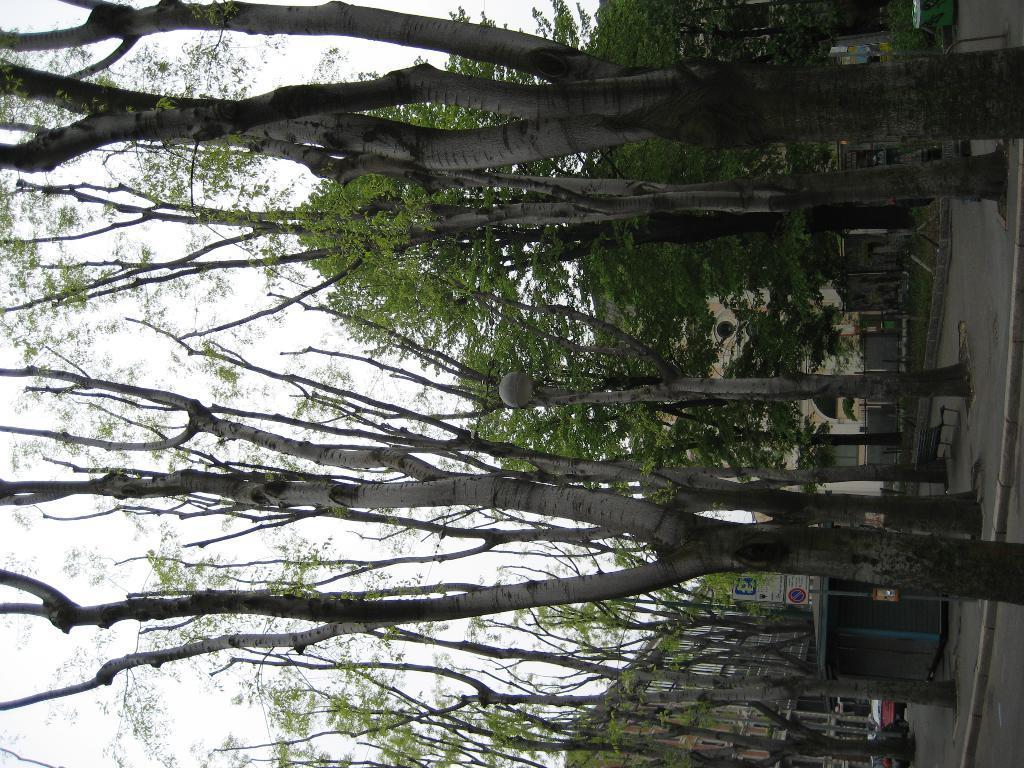How would you summarize this image in a sentence or two? In the center of the picture there are trees. In the center of the background there are buildings. 